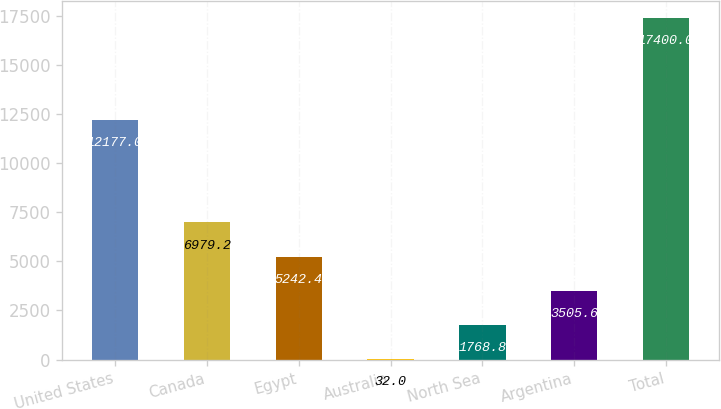<chart> <loc_0><loc_0><loc_500><loc_500><bar_chart><fcel>United States<fcel>Canada<fcel>Egypt<fcel>Australia<fcel>North Sea<fcel>Argentina<fcel>Total<nl><fcel>12177<fcel>6979.2<fcel>5242.4<fcel>32<fcel>1768.8<fcel>3505.6<fcel>17400<nl></chart> 